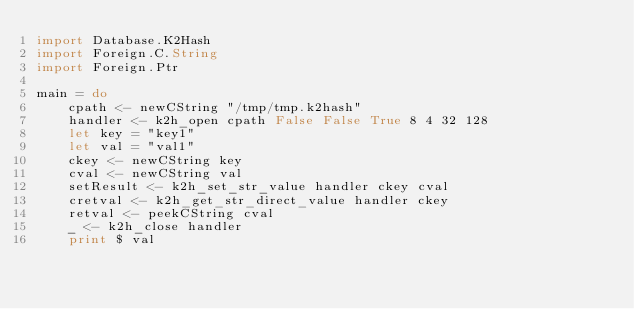Convert code to text. <code><loc_0><loc_0><loc_500><loc_500><_Haskell_>import Database.K2Hash
import Foreign.C.String
import Foreign.Ptr

main = do
    cpath <- newCString "/tmp/tmp.k2hash"
    handler <- k2h_open cpath False False True 8 4 32 128
    let key = "key1"
    let val = "val1"
    ckey <- newCString key
    cval <- newCString val
    setResult <- k2h_set_str_value handler ckey cval
    cretval <- k2h_get_str_direct_value handler ckey
    retval <- peekCString cval
    _ <- k2h_close handler
    print $ val

</code> 